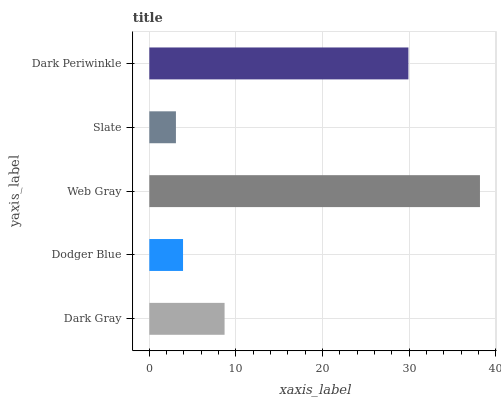Is Slate the minimum?
Answer yes or no. Yes. Is Web Gray the maximum?
Answer yes or no. Yes. Is Dodger Blue the minimum?
Answer yes or no. No. Is Dodger Blue the maximum?
Answer yes or no. No. Is Dark Gray greater than Dodger Blue?
Answer yes or no. Yes. Is Dodger Blue less than Dark Gray?
Answer yes or no. Yes. Is Dodger Blue greater than Dark Gray?
Answer yes or no. No. Is Dark Gray less than Dodger Blue?
Answer yes or no. No. Is Dark Gray the high median?
Answer yes or no. Yes. Is Dark Gray the low median?
Answer yes or no. Yes. Is Slate the high median?
Answer yes or no. No. Is Dodger Blue the low median?
Answer yes or no. No. 